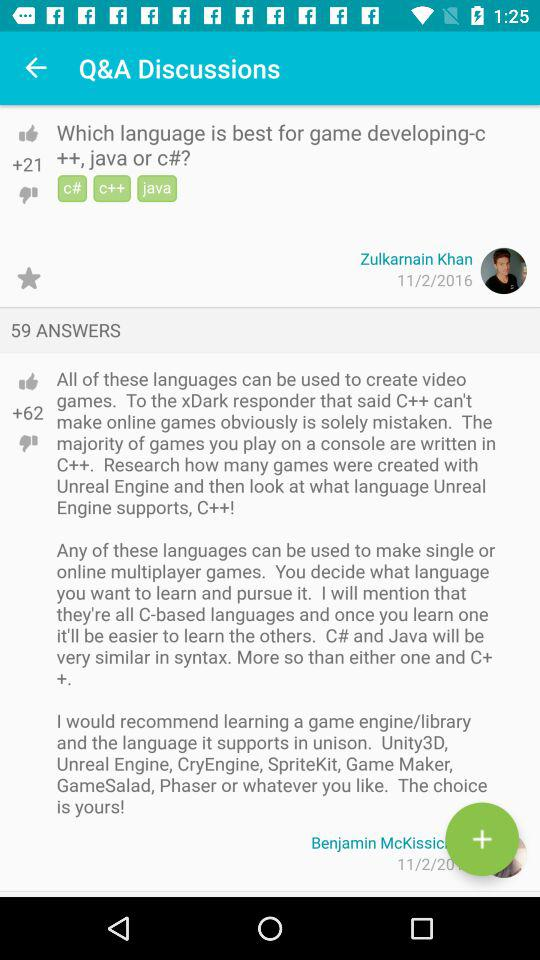What is the name of the user? The name of the user is Zulkarnain Khan. 